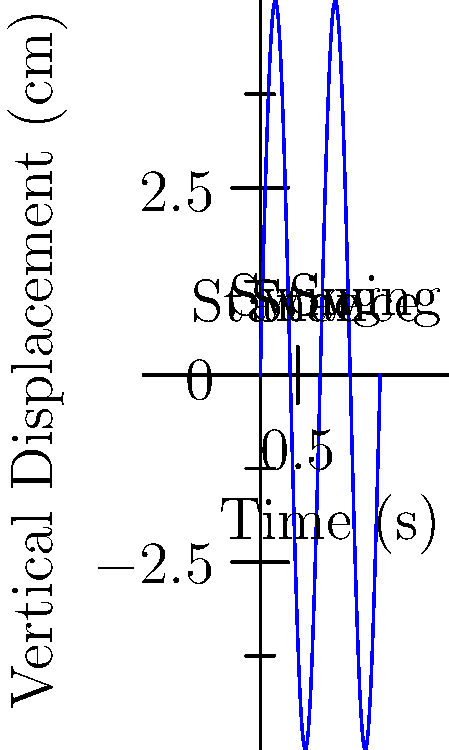Analyze the graph depicting the vertical displacement of a horse's hoof during a typical gait cycle of Westphalian cavalry horses. What is the approximate duration of a complete stride (in seconds) for these horses, and how might this have influenced their effectiveness in historical cavalry maneuvers? To answer this question, let's analyze the graph step-by-step:

1. The graph shows the vertical displacement of a horse's hoof over time during a gait cycle.

2. One complete gait cycle consists of two main phases: stance (when the hoof is in contact with the ground) and swing (when the hoof is in the air).

3. We can see that the graph completes two full cycles within the time frame shown.

4. The x-axis represents time in seconds, and it extends to 1.6 seconds.

5. To find the duration of one complete stride, we divide the total time by the number of cycles:

   $\text{Stride duration} = \frac{\text{Total time}}{\text{Number of cycles}} = \frac{1.6 \text{ seconds}}{2} = 0.8 \text{ seconds}$

6. This relatively short stride duration indicates a quick, efficient gait, which would have been advantageous for cavalry units in several ways:

   a) Speed: Faster strides allow for higher overall speed, crucial for charges and quick maneuvers.
   
   b) Stamina: An efficient gait helps conserve energy over long distances, important for extended campaigns.
   
   c) Agility: Shorter stride cycles can contribute to better responsiveness and ability to change direction quickly.
   
   d) Stability: A consistent, rapid gait cycle can provide a smoother ride for the cavalryman, allowing for better control and potentially improved accuracy with weapons.

7. In the context of Westphalian cavalry, known for their skilled horsemanship, this efficient gait would have enhanced their effectiveness in both battlefield charges and reconnaissance missions.
Answer: 0.8 seconds; enabled speed, stamina, agility, and stability for cavalry operations 